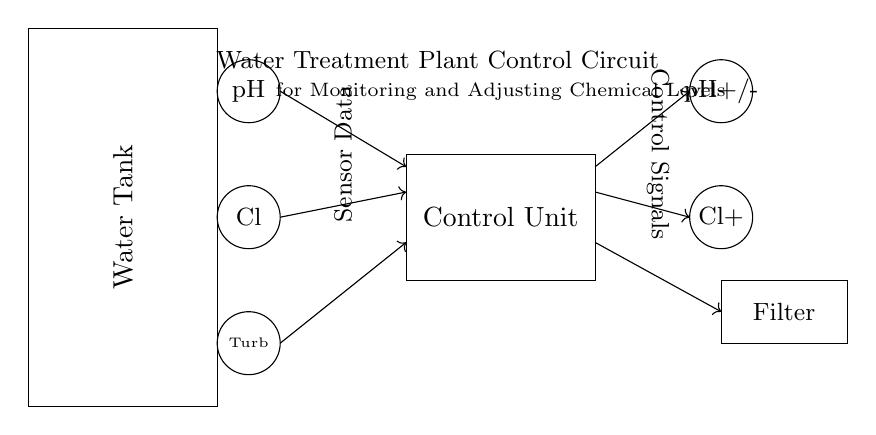What is the purpose of the pH sensor? The pH sensor is used to measure the acidity or alkalinity of the water in the treatment plant. It sends data to the control unit for monitoring.
Answer: Measure pH What regulates the chlorine levels in the water? The chlorine levels are regulated by the chlorine pump, which adjusts based on data received from the chlorine sensor.
Answer: Chlorine pump How many types of sensors are there in the circuit? There are three types of sensors: pH sensor, chlorine sensor, and turbidity sensor.
Answer: Three What is the flow direction of the sensor data? The sensor data flows from the sensors towards the control unit, indicated by the arrows pointing in that direction.
Answer: To the control unit Why is there a filtration system in the circuit? The filtration system is included to clean the water after chemical adjustments are made, ensuring treated water meets quality standards before distribution.
Answer: To clean water What component provides control signals for chemical adjustments? The control unit provides the control signals based on the data received from the sensors to manage the chemical adjustments.
Answer: Control unit 